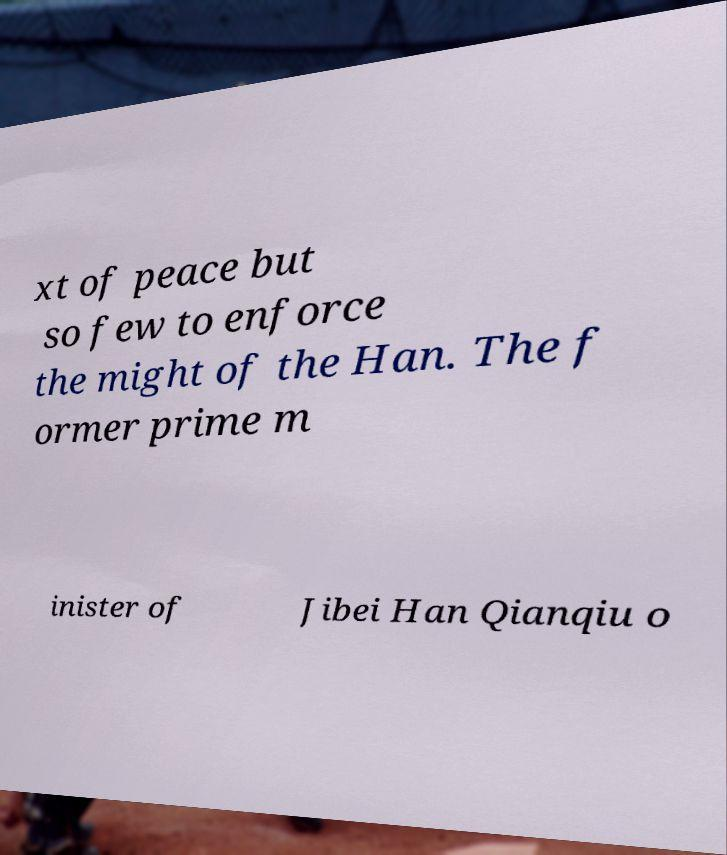Can you accurately transcribe the text from the provided image for me? xt of peace but so few to enforce the might of the Han. The f ormer prime m inister of Jibei Han Qianqiu o 